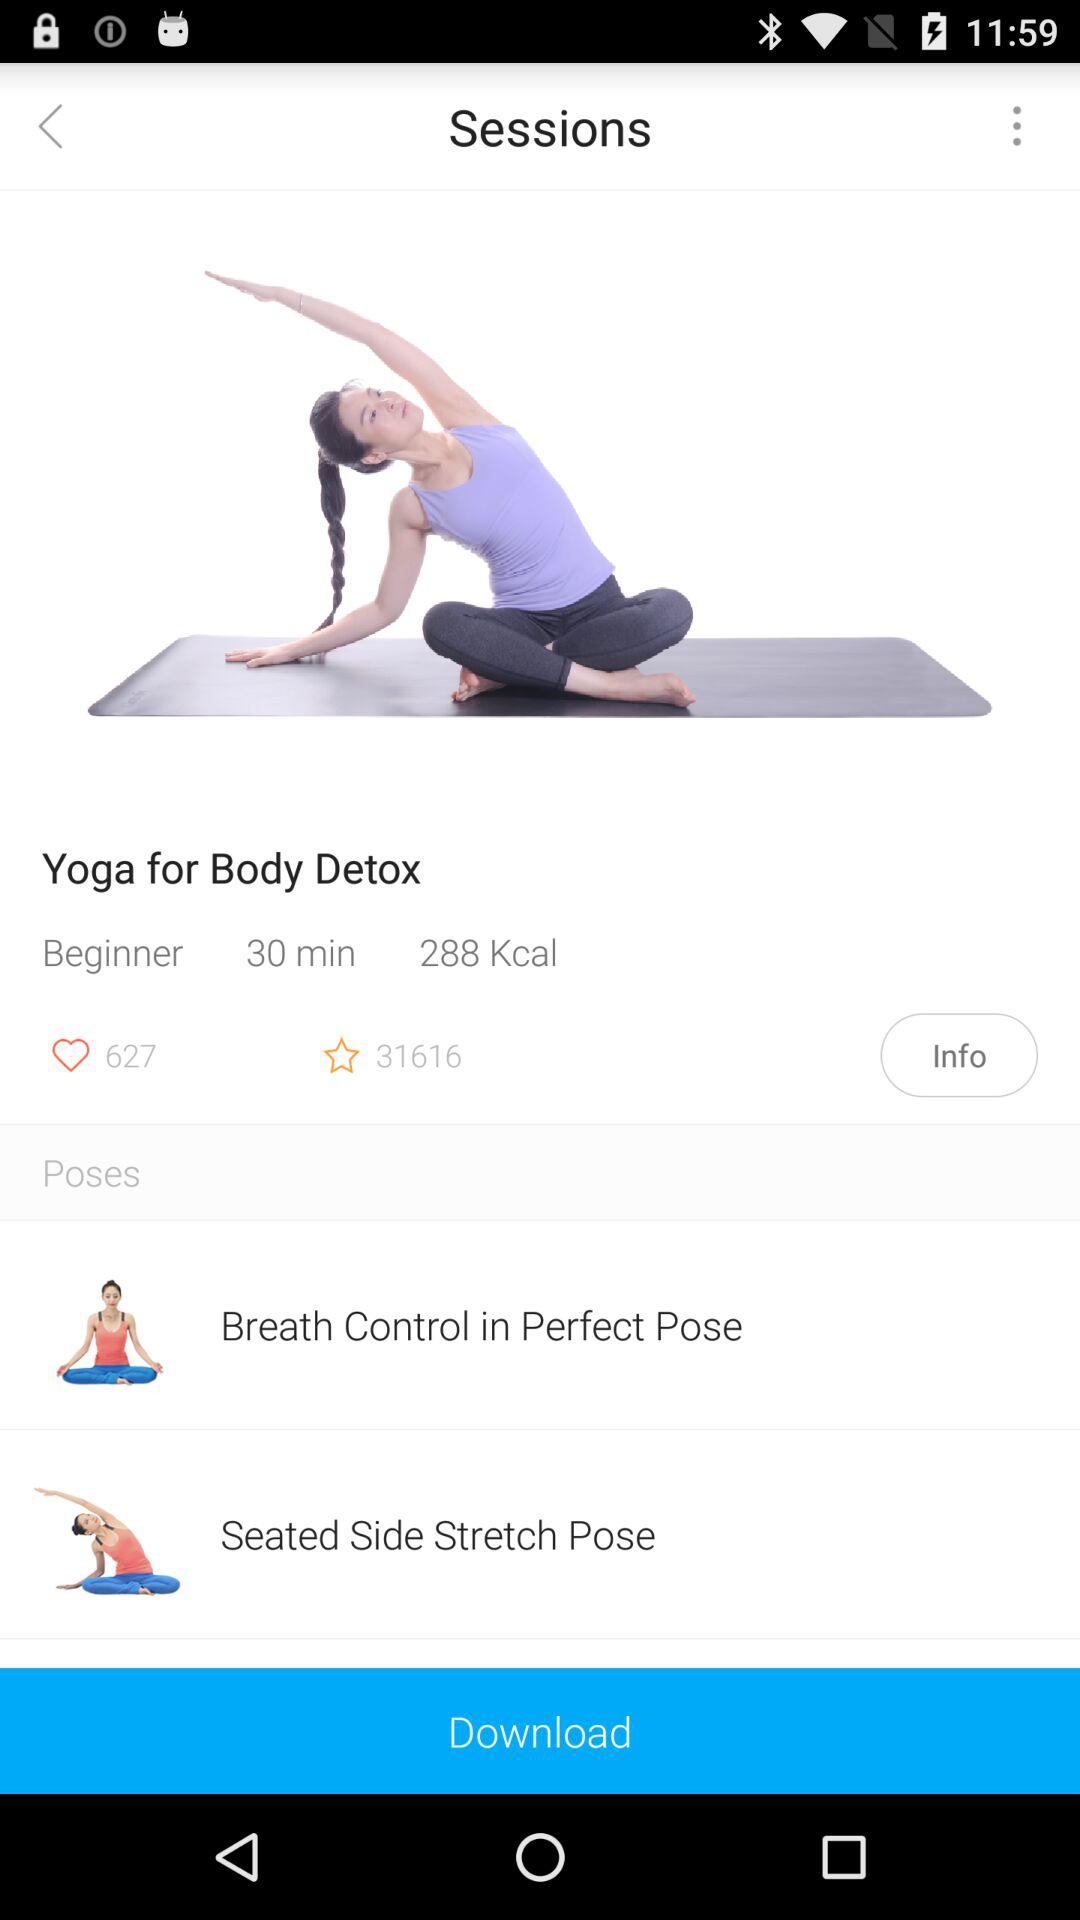How many users have rated the yoga session?
Answer the question using a single word or phrase. 31616 